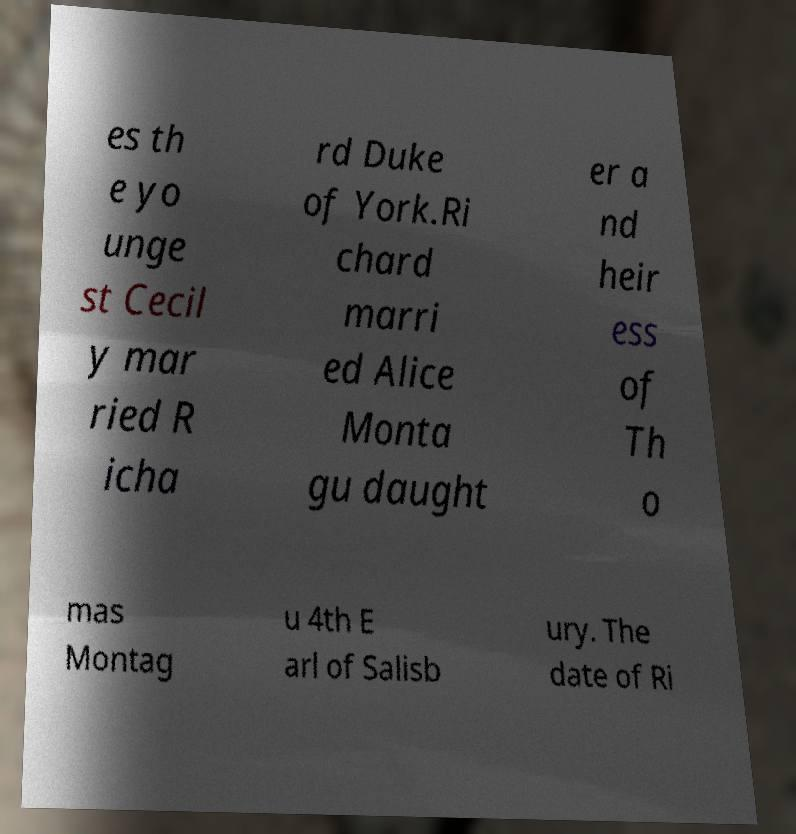Please identify and transcribe the text found in this image. es th e yo unge st Cecil y mar ried R icha rd Duke of York.Ri chard marri ed Alice Monta gu daught er a nd heir ess of Th o mas Montag u 4th E arl of Salisb ury. The date of Ri 